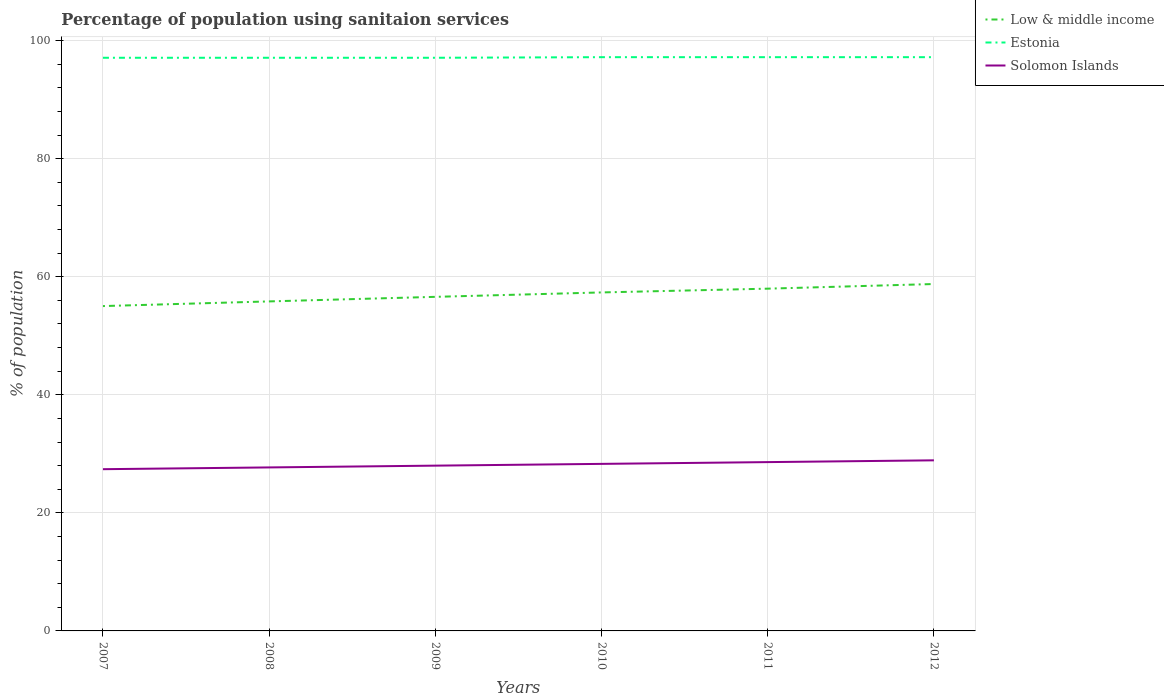Is the number of lines equal to the number of legend labels?
Ensure brevity in your answer.  Yes. Across all years, what is the maximum percentage of population using sanitaion services in Solomon Islands?
Keep it short and to the point. 27.4. In which year was the percentage of population using sanitaion services in Low & middle income maximum?
Your answer should be very brief. 2007. What is the total percentage of population using sanitaion services in Low & middle income in the graph?
Your answer should be very brief. -0.64. What is the difference between the highest and the second highest percentage of population using sanitaion services in Estonia?
Provide a succinct answer. 0.1. What is the difference between the highest and the lowest percentage of population using sanitaion services in Solomon Islands?
Your answer should be compact. 3. Is the percentage of population using sanitaion services in Solomon Islands strictly greater than the percentage of population using sanitaion services in Estonia over the years?
Your answer should be very brief. Yes. How many lines are there?
Your response must be concise. 3. How many years are there in the graph?
Your response must be concise. 6. Does the graph contain grids?
Offer a terse response. Yes. Where does the legend appear in the graph?
Ensure brevity in your answer.  Top right. How many legend labels are there?
Provide a short and direct response. 3. What is the title of the graph?
Keep it short and to the point. Percentage of population using sanitaion services. Does "Grenada" appear as one of the legend labels in the graph?
Give a very brief answer. No. What is the label or title of the X-axis?
Your answer should be very brief. Years. What is the label or title of the Y-axis?
Make the answer very short. % of population. What is the % of population in Low & middle income in 2007?
Provide a short and direct response. 55.03. What is the % of population of Estonia in 2007?
Ensure brevity in your answer.  97.1. What is the % of population of Solomon Islands in 2007?
Keep it short and to the point. 27.4. What is the % of population of Low & middle income in 2008?
Your response must be concise. 55.82. What is the % of population of Estonia in 2008?
Your response must be concise. 97.1. What is the % of population in Solomon Islands in 2008?
Your answer should be very brief. 27.7. What is the % of population in Low & middle income in 2009?
Your answer should be compact. 56.6. What is the % of population in Estonia in 2009?
Offer a very short reply. 97.1. What is the % of population in Solomon Islands in 2009?
Your response must be concise. 28. What is the % of population in Low & middle income in 2010?
Your answer should be compact. 57.34. What is the % of population of Estonia in 2010?
Provide a succinct answer. 97.2. What is the % of population in Solomon Islands in 2010?
Your response must be concise. 28.3. What is the % of population in Low & middle income in 2011?
Provide a succinct answer. 57.98. What is the % of population of Estonia in 2011?
Ensure brevity in your answer.  97.2. What is the % of population in Solomon Islands in 2011?
Ensure brevity in your answer.  28.6. What is the % of population of Low & middle income in 2012?
Make the answer very short. 58.77. What is the % of population in Estonia in 2012?
Make the answer very short. 97.2. What is the % of population of Solomon Islands in 2012?
Provide a short and direct response. 28.9. Across all years, what is the maximum % of population in Low & middle income?
Your answer should be compact. 58.77. Across all years, what is the maximum % of population of Estonia?
Offer a terse response. 97.2. Across all years, what is the maximum % of population in Solomon Islands?
Offer a very short reply. 28.9. Across all years, what is the minimum % of population in Low & middle income?
Provide a short and direct response. 55.03. Across all years, what is the minimum % of population in Estonia?
Ensure brevity in your answer.  97.1. Across all years, what is the minimum % of population of Solomon Islands?
Keep it short and to the point. 27.4. What is the total % of population in Low & middle income in the graph?
Your answer should be compact. 341.55. What is the total % of population in Estonia in the graph?
Ensure brevity in your answer.  582.9. What is the total % of population in Solomon Islands in the graph?
Provide a succinct answer. 168.9. What is the difference between the % of population of Low & middle income in 2007 and that in 2008?
Ensure brevity in your answer.  -0.79. What is the difference between the % of population of Solomon Islands in 2007 and that in 2008?
Provide a short and direct response. -0.3. What is the difference between the % of population in Low & middle income in 2007 and that in 2009?
Your response must be concise. -1.56. What is the difference between the % of population of Low & middle income in 2007 and that in 2010?
Make the answer very short. -2.31. What is the difference between the % of population of Solomon Islands in 2007 and that in 2010?
Your response must be concise. -0.9. What is the difference between the % of population of Low & middle income in 2007 and that in 2011?
Give a very brief answer. -2.95. What is the difference between the % of population of Estonia in 2007 and that in 2011?
Ensure brevity in your answer.  -0.1. What is the difference between the % of population in Low & middle income in 2007 and that in 2012?
Offer a very short reply. -3.74. What is the difference between the % of population of Estonia in 2007 and that in 2012?
Make the answer very short. -0.1. What is the difference between the % of population in Solomon Islands in 2007 and that in 2012?
Your answer should be compact. -1.5. What is the difference between the % of population of Low & middle income in 2008 and that in 2009?
Make the answer very short. -0.77. What is the difference between the % of population in Low & middle income in 2008 and that in 2010?
Keep it short and to the point. -1.52. What is the difference between the % of population of Estonia in 2008 and that in 2010?
Provide a succinct answer. -0.1. What is the difference between the % of population in Low & middle income in 2008 and that in 2011?
Offer a very short reply. -2.16. What is the difference between the % of population of Estonia in 2008 and that in 2011?
Offer a terse response. -0.1. What is the difference between the % of population of Low & middle income in 2008 and that in 2012?
Provide a succinct answer. -2.95. What is the difference between the % of population of Low & middle income in 2009 and that in 2010?
Offer a very short reply. -0.75. What is the difference between the % of population in Low & middle income in 2009 and that in 2011?
Offer a terse response. -1.39. What is the difference between the % of population of Solomon Islands in 2009 and that in 2011?
Provide a short and direct response. -0.6. What is the difference between the % of population in Low & middle income in 2009 and that in 2012?
Your answer should be compact. -2.17. What is the difference between the % of population of Estonia in 2009 and that in 2012?
Make the answer very short. -0.1. What is the difference between the % of population in Low & middle income in 2010 and that in 2011?
Your response must be concise. -0.64. What is the difference between the % of population of Estonia in 2010 and that in 2011?
Keep it short and to the point. 0. What is the difference between the % of population of Low & middle income in 2010 and that in 2012?
Provide a succinct answer. -1.43. What is the difference between the % of population in Estonia in 2010 and that in 2012?
Provide a succinct answer. 0. What is the difference between the % of population in Solomon Islands in 2010 and that in 2012?
Your answer should be compact. -0.6. What is the difference between the % of population of Low & middle income in 2011 and that in 2012?
Your response must be concise. -0.79. What is the difference between the % of population of Low & middle income in 2007 and the % of population of Estonia in 2008?
Your answer should be compact. -42.07. What is the difference between the % of population in Low & middle income in 2007 and the % of population in Solomon Islands in 2008?
Make the answer very short. 27.33. What is the difference between the % of population in Estonia in 2007 and the % of population in Solomon Islands in 2008?
Your answer should be compact. 69.4. What is the difference between the % of population in Low & middle income in 2007 and the % of population in Estonia in 2009?
Make the answer very short. -42.07. What is the difference between the % of population in Low & middle income in 2007 and the % of population in Solomon Islands in 2009?
Keep it short and to the point. 27.03. What is the difference between the % of population of Estonia in 2007 and the % of population of Solomon Islands in 2009?
Offer a very short reply. 69.1. What is the difference between the % of population of Low & middle income in 2007 and the % of population of Estonia in 2010?
Offer a very short reply. -42.17. What is the difference between the % of population in Low & middle income in 2007 and the % of population in Solomon Islands in 2010?
Give a very brief answer. 26.73. What is the difference between the % of population in Estonia in 2007 and the % of population in Solomon Islands in 2010?
Ensure brevity in your answer.  68.8. What is the difference between the % of population of Low & middle income in 2007 and the % of population of Estonia in 2011?
Keep it short and to the point. -42.17. What is the difference between the % of population in Low & middle income in 2007 and the % of population in Solomon Islands in 2011?
Your answer should be compact. 26.43. What is the difference between the % of population of Estonia in 2007 and the % of population of Solomon Islands in 2011?
Your answer should be compact. 68.5. What is the difference between the % of population in Low & middle income in 2007 and the % of population in Estonia in 2012?
Ensure brevity in your answer.  -42.17. What is the difference between the % of population of Low & middle income in 2007 and the % of population of Solomon Islands in 2012?
Make the answer very short. 26.13. What is the difference between the % of population in Estonia in 2007 and the % of population in Solomon Islands in 2012?
Provide a short and direct response. 68.2. What is the difference between the % of population in Low & middle income in 2008 and the % of population in Estonia in 2009?
Offer a terse response. -41.28. What is the difference between the % of population of Low & middle income in 2008 and the % of population of Solomon Islands in 2009?
Keep it short and to the point. 27.82. What is the difference between the % of population in Estonia in 2008 and the % of population in Solomon Islands in 2009?
Provide a short and direct response. 69.1. What is the difference between the % of population of Low & middle income in 2008 and the % of population of Estonia in 2010?
Your response must be concise. -41.38. What is the difference between the % of population in Low & middle income in 2008 and the % of population in Solomon Islands in 2010?
Provide a succinct answer. 27.52. What is the difference between the % of population in Estonia in 2008 and the % of population in Solomon Islands in 2010?
Provide a succinct answer. 68.8. What is the difference between the % of population of Low & middle income in 2008 and the % of population of Estonia in 2011?
Make the answer very short. -41.38. What is the difference between the % of population in Low & middle income in 2008 and the % of population in Solomon Islands in 2011?
Provide a short and direct response. 27.22. What is the difference between the % of population of Estonia in 2008 and the % of population of Solomon Islands in 2011?
Your answer should be very brief. 68.5. What is the difference between the % of population of Low & middle income in 2008 and the % of population of Estonia in 2012?
Your answer should be very brief. -41.38. What is the difference between the % of population in Low & middle income in 2008 and the % of population in Solomon Islands in 2012?
Offer a very short reply. 26.92. What is the difference between the % of population of Estonia in 2008 and the % of population of Solomon Islands in 2012?
Provide a succinct answer. 68.2. What is the difference between the % of population of Low & middle income in 2009 and the % of population of Estonia in 2010?
Offer a very short reply. -40.6. What is the difference between the % of population in Low & middle income in 2009 and the % of population in Solomon Islands in 2010?
Provide a short and direct response. 28.3. What is the difference between the % of population of Estonia in 2009 and the % of population of Solomon Islands in 2010?
Your answer should be very brief. 68.8. What is the difference between the % of population of Low & middle income in 2009 and the % of population of Estonia in 2011?
Offer a very short reply. -40.6. What is the difference between the % of population of Low & middle income in 2009 and the % of population of Solomon Islands in 2011?
Make the answer very short. 28. What is the difference between the % of population of Estonia in 2009 and the % of population of Solomon Islands in 2011?
Make the answer very short. 68.5. What is the difference between the % of population of Low & middle income in 2009 and the % of population of Estonia in 2012?
Give a very brief answer. -40.6. What is the difference between the % of population of Low & middle income in 2009 and the % of population of Solomon Islands in 2012?
Give a very brief answer. 27.7. What is the difference between the % of population in Estonia in 2009 and the % of population in Solomon Islands in 2012?
Give a very brief answer. 68.2. What is the difference between the % of population in Low & middle income in 2010 and the % of population in Estonia in 2011?
Offer a very short reply. -39.86. What is the difference between the % of population in Low & middle income in 2010 and the % of population in Solomon Islands in 2011?
Keep it short and to the point. 28.74. What is the difference between the % of population in Estonia in 2010 and the % of population in Solomon Islands in 2011?
Provide a short and direct response. 68.6. What is the difference between the % of population of Low & middle income in 2010 and the % of population of Estonia in 2012?
Make the answer very short. -39.86. What is the difference between the % of population in Low & middle income in 2010 and the % of population in Solomon Islands in 2012?
Your response must be concise. 28.44. What is the difference between the % of population of Estonia in 2010 and the % of population of Solomon Islands in 2012?
Offer a terse response. 68.3. What is the difference between the % of population in Low & middle income in 2011 and the % of population in Estonia in 2012?
Give a very brief answer. -39.22. What is the difference between the % of population of Low & middle income in 2011 and the % of population of Solomon Islands in 2012?
Offer a very short reply. 29.08. What is the difference between the % of population of Estonia in 2011 and the % of population of Solomon Islands in 2012?
Your answer should be compact. 68.3. What is the average % of population of Low & middle income per year?
Keep it short and to the point. 56.93. What is the average % of population of Estonia per year?
Your answer should be very brief. 97.15. What is the average % of population of Solomon Islands per year?
Keep it short and to the point. 28.15. In the year 2007, what is the difference between the % of population in Low & middle income and % of population in Estonia?
Offer a very short reply. -42.07. In the year 2007, what is the difference between the % of population in Low & middle income and % of population in Solomon Islands?
Your answer should be very brief. 27.63. In the year 2007, what is the difference between the % of population of Estonia and % of population of Solomon Islands?
Offer a very short reply. 69.7. In the year 2008, what is the difference between the % of population of Low & middle income and % of population of Estonia?
Provide a short and direct response. -41.28. In the year 2008, what is the difference between the % of population of Low & middle income and % of population of Solomon Islands?
Keep it short and to the point. 28.12. In the year 2008, what is the difference between the % of population of Estonia and % of population of Solomon Islands?
Offer a terse response. 69.4. In the year 2009, what is the difference between the % of population of Low & middle income and % of population of Estonia?
Your answer should be very brief. -40.5. In the year 2009, what is the difference between the % of population in Low & middle income and % of population in Solomon Islands?
Offer a terse response. 28.6. In the year 2009, what is the difference between the % of population of Estonia and % of population of Solomon Islands?
Give a very brief answer. 69.1. In the year 2010, what is the difference between the % of population of Low & middle income and % of population of Estonia?
Make the answer very short. -39.86. In the year 2010, what is the difference between the % of population in Low & middle income and % of population in Solomon Islands?
Provide a short and direct response. 29.04. In the year 2010, what is the difference between the % of population of Estonia and % of population of Solomon Islands?
Offer a very short reply. 68.9. In the year 2011, what is the difference between the % of population of Low & middle income and % of population of Estonia?
Make the answer very short. -39.22. In the year 2011, what is the difference between the % of population in Low & middle income and % of population in Solomon Islands?
Your response must be concise. 29.38. In the year 2011, what is the difference between the % of population in Estonia and % of population in Solomon Islands?
Your answer should be compact. 68.6. In the year 2012, what is the difference between the % of population in Low & middle income and % of population in Estonia?
Provide a short and direct response. -38.43. In the year 2012, what is the difference between the % of population in Low & middle income and % of population in Solomon Islands?
Keep it short and to the point. 29.87. In the year 2012, what is the difference between the % of population in Estonia and % of population in Solomon Islands?
Offer a very short reply. 68.3. What is the ratio of the % of population of Low & middle income in 2007 to that in 2008?
Your answer should be very brief. 0.99. What is the ratio of the % of population in Solomon Islands in 2007 to that in 2008?
Ensure brevity in your answer.  0.99. What is the ratio of the % of population of Low & middle income in 2007 to that in 2009?
Provide a short and direct response. 0.97. What is the ratio of the % of population of Solomon Islands in 2007 to that in 2009?
Offer a very short reply. 0.98. What is the ratio of the % of population in Low & middle income in 2007 to that in 2010?
Offer a very short reply. 0.96. What is the ratio of the % of population of Solomon Islands in 2007 to that in 2010?
Offer a very short reply. 0.97. What is the ratio of the % of population of Low & middle income in 2007 to that in 2011?
Offer a terse response. 0.95. What is the ratio of the % of population of Estonia in 2007 to that in 2011?
Offer a very short reply. 1. What is the ratio of the % of population of Solomon Islands in 2007 to that in 2011?
Offer a terse response. 0.96. What is the ratio of the % of population in Low & middle income in 2007 to that in 2012?
Offer a terse response. 0.94. What is the ratio of the % of population of Solomon Islands in 2007 to that in 2012?
Give a very brief answer. 0.95. What is the ratio of the % of population in Low & middle income in 2008 to that in 2009?
Your answer should be very brief. 0.99. What is the ratio of the % of population in Solomon Islands in 2008 to that in 2009?
Provide a short and direct response. 0.99. What is the ratio of the % of population of Low & middle income in 2008 to that in 2010?
Keep it short and to the point. 0.97. What is the ratio of the % of population of Estonia in 2008 to that in 2010?
Keep it short and to the point. 1. What is the ratio of the % of population of Solomon Islands in 2008 to that in 2010?
Offer a very short reply. 0.98. What is the ratio of the % of population in Low & middle income in 2008 to that in 2011?
Keep it short and to the point. 0.96. What is the ratio of the % of population of Estonia in 2008 to that in 2011?
Keep it short and to the point. 1. What is the ratio of the % of population in Solomon Islands in 2008 to that in 2011?
Provide a short and direct response. 0.97. What is the ratio of the % of population of Low & middle income in 2008 to that in 2012?
Give a very brief answer. 0.95. What is the ratio of the % of population of Solomon Islands in 2008 to that in 2012?
Keep it short and to the point. 0.96. What is the ratio of the % of population of Low & middle income in 2009 to that in 2010?
Provide a succinct answer. 0.99. What is the ratio of the % of population of Solomon Islands in 2009 to that in 2010?
Your answer should be compact. 0.99. What is the ratio of the % of population of Low & middle income in 2009 to that in 2011?
Keep it short and to the point. 0.98. What is the ratio of the % of population in Solomon Islands in 2009 to that in 2011?
Your answer should be compact. 0.98. What is the ratio of the % of population of Estonia in 2009 to that in 2012?
Your answer should be compact. 1. What is the ratio of the % of population of Solomon Islands in 2009 to that in 2012?
Your answer should be compact. 0.97. What is the ratio of the % of population of Low & middle income in 2010 to that in 2011?
Your response must be concise. 0.99. What is the ratio of the % of population of Solomon Islands in 2010 to that in 2011?
Provide a succinct answer. 0.99. What is the ratio of the % of population of Low & middle income in 2010 to that in 2012?
Provide a short and direct response. 0.98. What is the ratio of the % of population in Estonia in 2010 to that in 2012?
Give a very brief answer. 1. What is the ratio of the % of population in Solomon Islands in 2010 to that in 2012?
Your answer should be compact. 0.98. What is the ratio of the % of population in Low & middle income in 2011 to that in 2012?
Keep it short and to the point. 0.99. What is the ratio of the % of population of Solomon Islands in 2011 to that in 2012?
Give a very brief answer. 0.99. What is the difference between the highest and the second highest % of population of Low & middle income?
Give a very brief answer. 0.79. What is the difference between the highest and the second highest % of population of Estonia?
Provide a short and direct response. 0. What is the difference between the highest and the lowest % of population of Low & middle income?
Make the answer very short. 3.74. What is the difference between the highest and the lowest % of population of Estonia?
Offer a terse response. 0.1. 